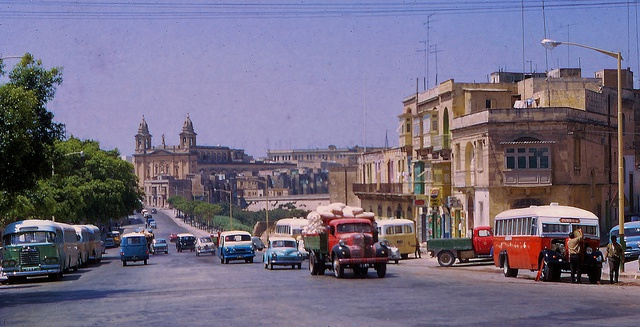Describe the objects in this image and their specific colors. I can see car in gray, black, lightgray, and maroon tones, bus in gray, black, lightgray, and brown tones, truck in gray, black, maroon, and lightgray tones, bus in gray, black, navy, and blue tones, and truck in gray, black, maroon, and brown tones in this image. 